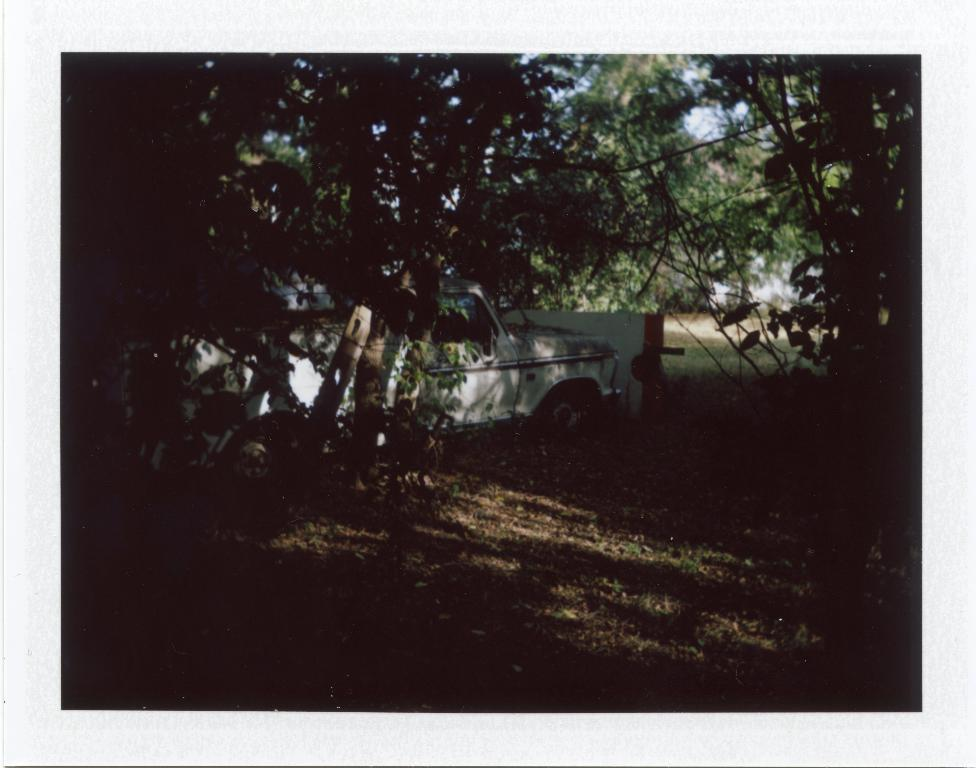What is the overall lighting condition of the image? The image is dark. What type of surface can be seen in the image? There is ground visible in the image. What type of vegetation is present in the image? There are green trees in the image. What color is the vehicle in the image? The vehicle in the image is white-colored. What part of the natural environment is visible in the background of the image? The sky is visible in the background of the image. Can you tell me how many children are swinging on the swing in the image? There is no swing present in the image. What type of sorting method is being used by the caretaker in the image? There is no caretaker or sorting method present in the image. 